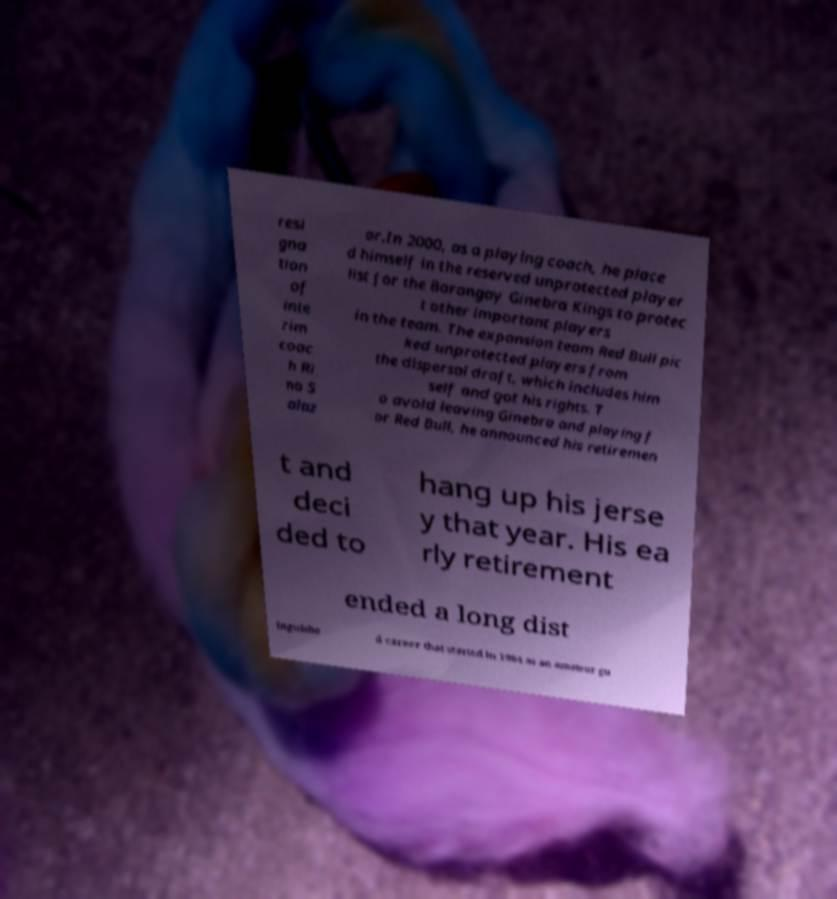Can you accurately transcribe the text from the provided image for me? resi gna tion of inte rim coac h Ri no S alaz ar.In 2000, as a playing coach, he place d himself in the reserved unprotected player list for the Barangay Ginebra Kings to protec t other important players in the team. The expansion team Red Bull pic ked unprotected players from the dispersal draft, which includes him self and got his rights. T o avoid leaving Ginebra and playing f or Red Bull, he announced his retiremen t and deci ded to hang up his jerse y that year. His ea rly retirement ended a long dist inguishe d career that started in 1984 as an amateur gu 